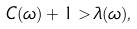<formula> <loc_0><loc_0><loc_500><loc_500>C ( \omega ) + 1 > \lambda ( \omega ) ,</formula> 